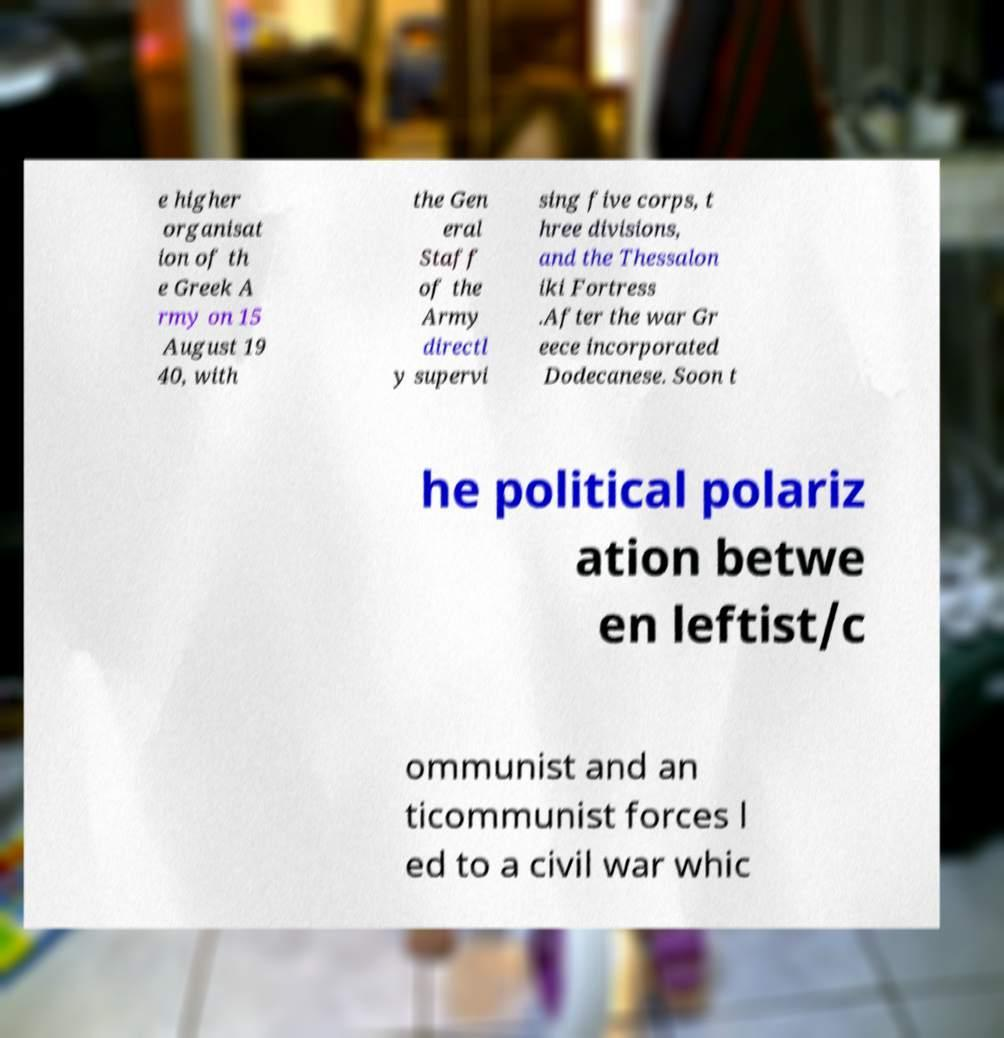There's text embedded in this image that I need extracted. Can you transcribe it verbatim? e higher organisat ion of th e Greek A rmy on 15 August 19 40, with the Gen eral Staff of the Army directl y supervi sing five corps, t hree divisions, and the Thessalon iki Fortress .After the war Gr eece incorporated Dodecanese. Soon t he political polariz ation betwe en leftist/c ommunist and an ticommunist forces l ed to a civil war whic 